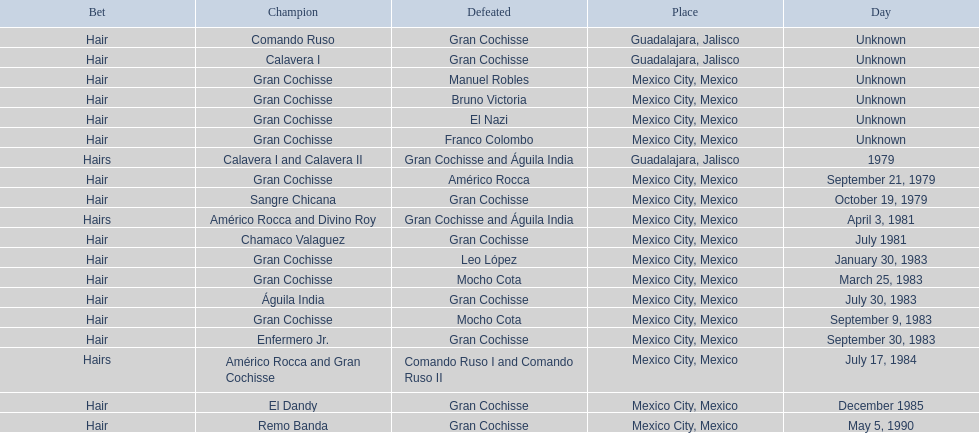What was the number of losses gran cochisse had against el dandy? 1. 